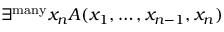Convert formula to latex. <formula><loc_0><loc_0><loc_500><loc_500>\exists ^ { m a n y } x _ { n } A ( x _ { 1 } , \dots , x _ { n - 1 } , x _ { n } )</formula> 